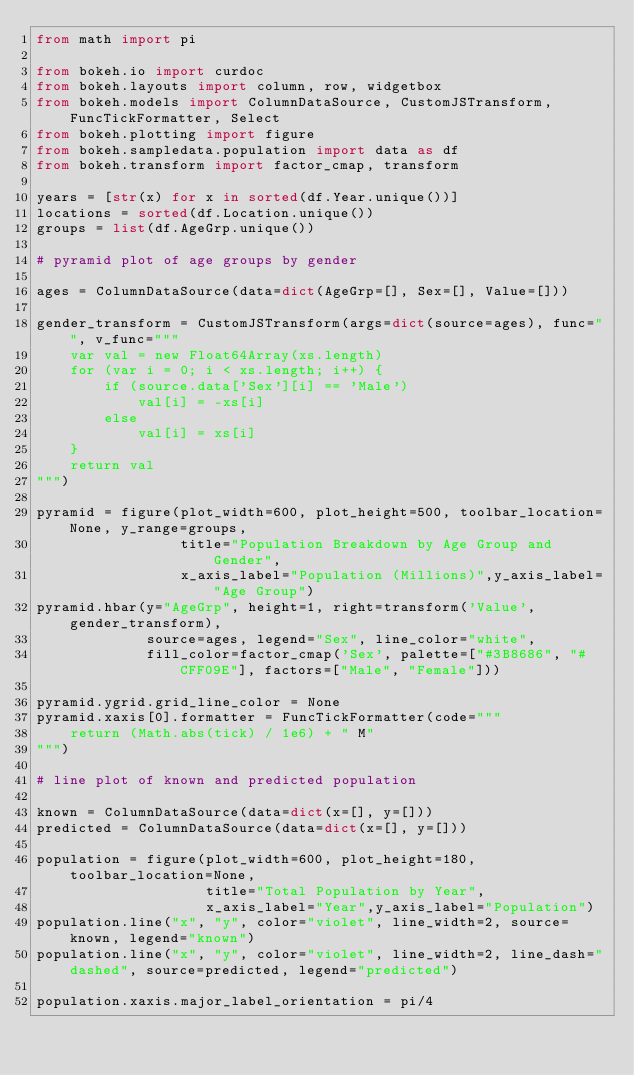Convert code to text. <code><loc_0><loc_0><loc_500><loc_500><_Python_>from math import pi

from bokeh.io import curdoc
from bokeh.layouts import column, row, widgetbox
from bokeh.models import ColumnDataSource, CustomJSTransform, FuncTickFormatter, Select
from bokeh.plotting import figure
from bokeh.sampledata.population import data as df
from bokeh.transform import factor_cmap, transform

years = [str(x) for x in sorted(df.Year.unique())]
locations = sorted(df.Location.unique())
groups = list(df.AgeGrp.unique())

# pyramid plot of age groups by gender

ages = ColumnDataSource(data=dict(AgeGrp=[], Sex=[], Value=[]))

gender_transform = CustomJSTransform(args=dict(source=ages), func="", v_func="""
    var val = new Float64Array(xs.length)
    for (var i = 0; i < xs.length; i++) {
        if (source.data['Sex'][i] == 'Male')
            val[i] = -xs[i]
        else
            val[i] = xs[i]
    }
    return val
""")

pyramid = figure(plot_width=600, plot_height=500, toolbar_location=None, y_range=groups,
                 title="Population Breakdown by Age Group and Gender",
                 x_axis_label="Population (Millions)",y_axis_label="Age Group")
pyramid.hbar(y="AgeGrp", height=1, right=transform('Value', gender_transform),
             source=ages, legend="Sex", line_color="white",
             fill_color=factor_cmap('Sex', palette=["#3B8686", "#CFF09E"], factors=["Male", "Female"]))

pyramid.ygrid.grid_line_color = None
pyramid.xaxis[0].formatter = FuncTickFormatter(code="""
    return (Math.abs(tick) / 1e6) + " M"
""")

# line plot of known and predicted population

known = ColumnDataSource(data=dict(x=[], y=[]))
predicted = ColumnDataSource(data=dict(x=[], y=[]))

population = figure(plot_width=600, plot_height=180, toolbar_location=None,
                    title="Total Population by Year",
                    x_axis_label="Year",y_axis_label="Population")
population.line("x", "y", color="violet", line_width=2, source=known, legend="known")
population.line("x", "y", color="violet", line_width=2, line_dash="dashed", source=predicted, legend="predicted")

population.xaxis.major_label_orientation = pi/4</code> 